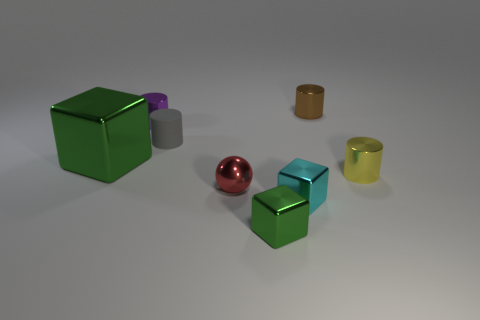Add 1 small yellow shiny objects. How many objects exist? 9 Subtract all blocks. How many objects are left? 5 Add 2 spheres. How many spheres are left? 3 Add 5 cyan metallic objects. How many cyan metallic objects exist? 6 Subtract 0 gray balls. How many objects are left? 8 Subtract all large objects. Subtract all tiny red objects. How many objects are left? 6 